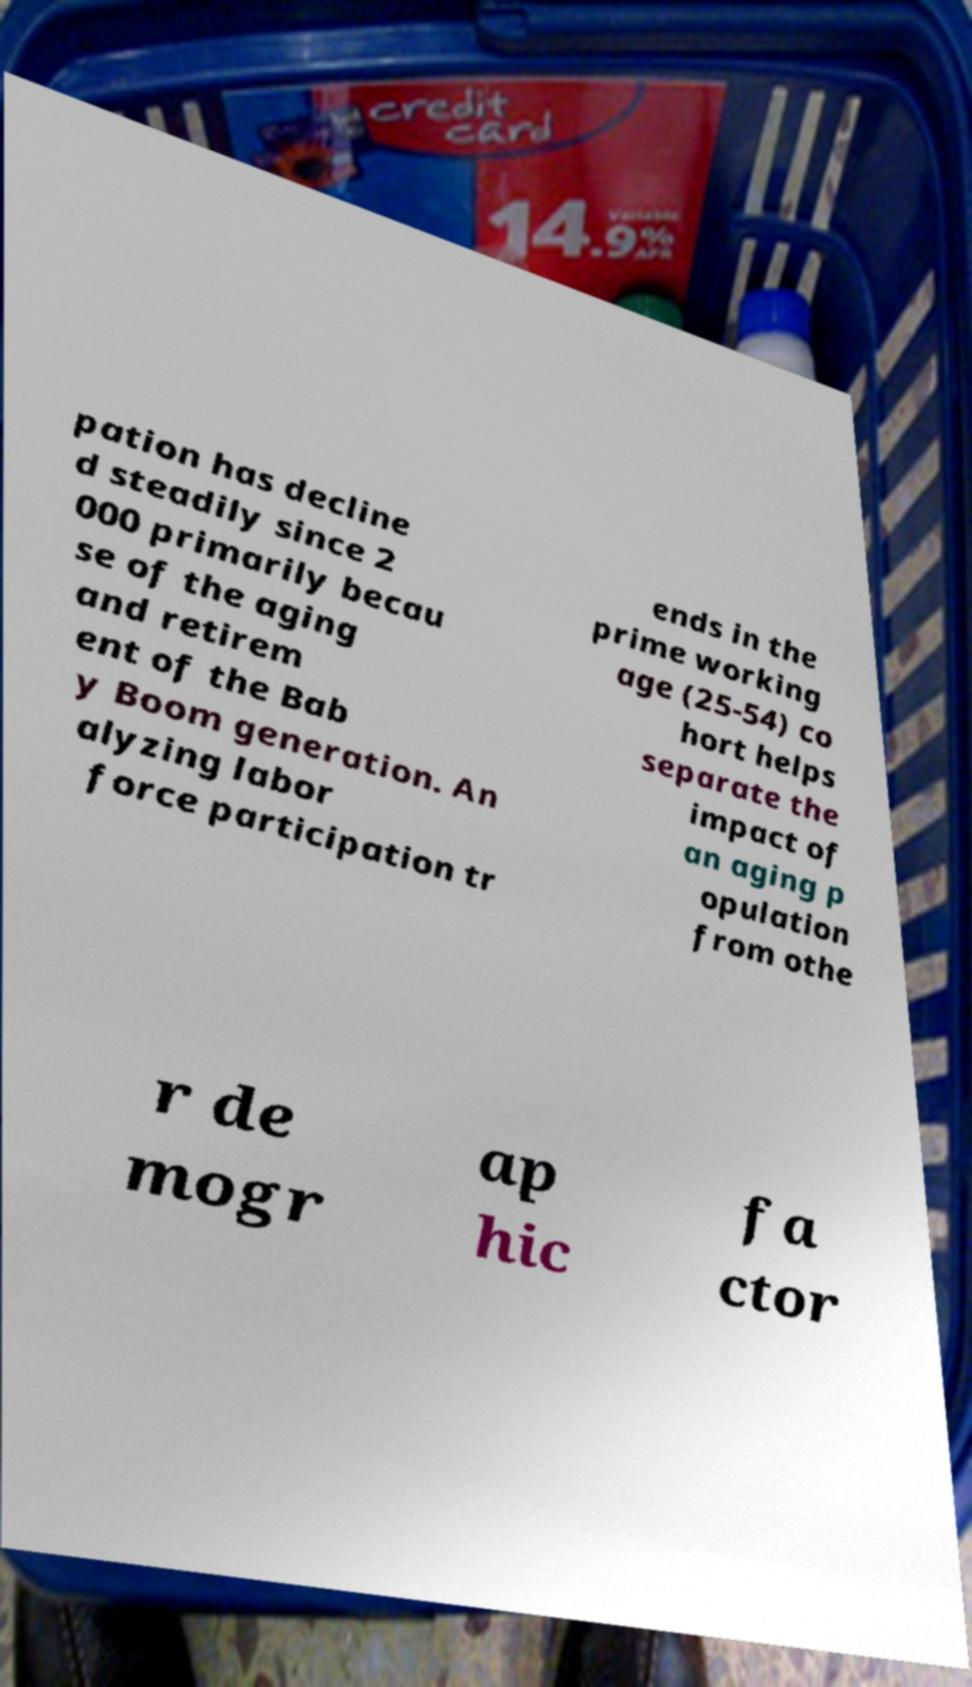Please read and relay the text visible in this image. What does it say? pation has decline d steadily since 2 000 primarily becau se of the aging and retirem ent of the Bab y Boom generation. An alyzing labor force participation tr ends in the prime working age (25-54) co hort helps separate the impact of an aging p opulation from othe r de mogr ap hic fa ctor 